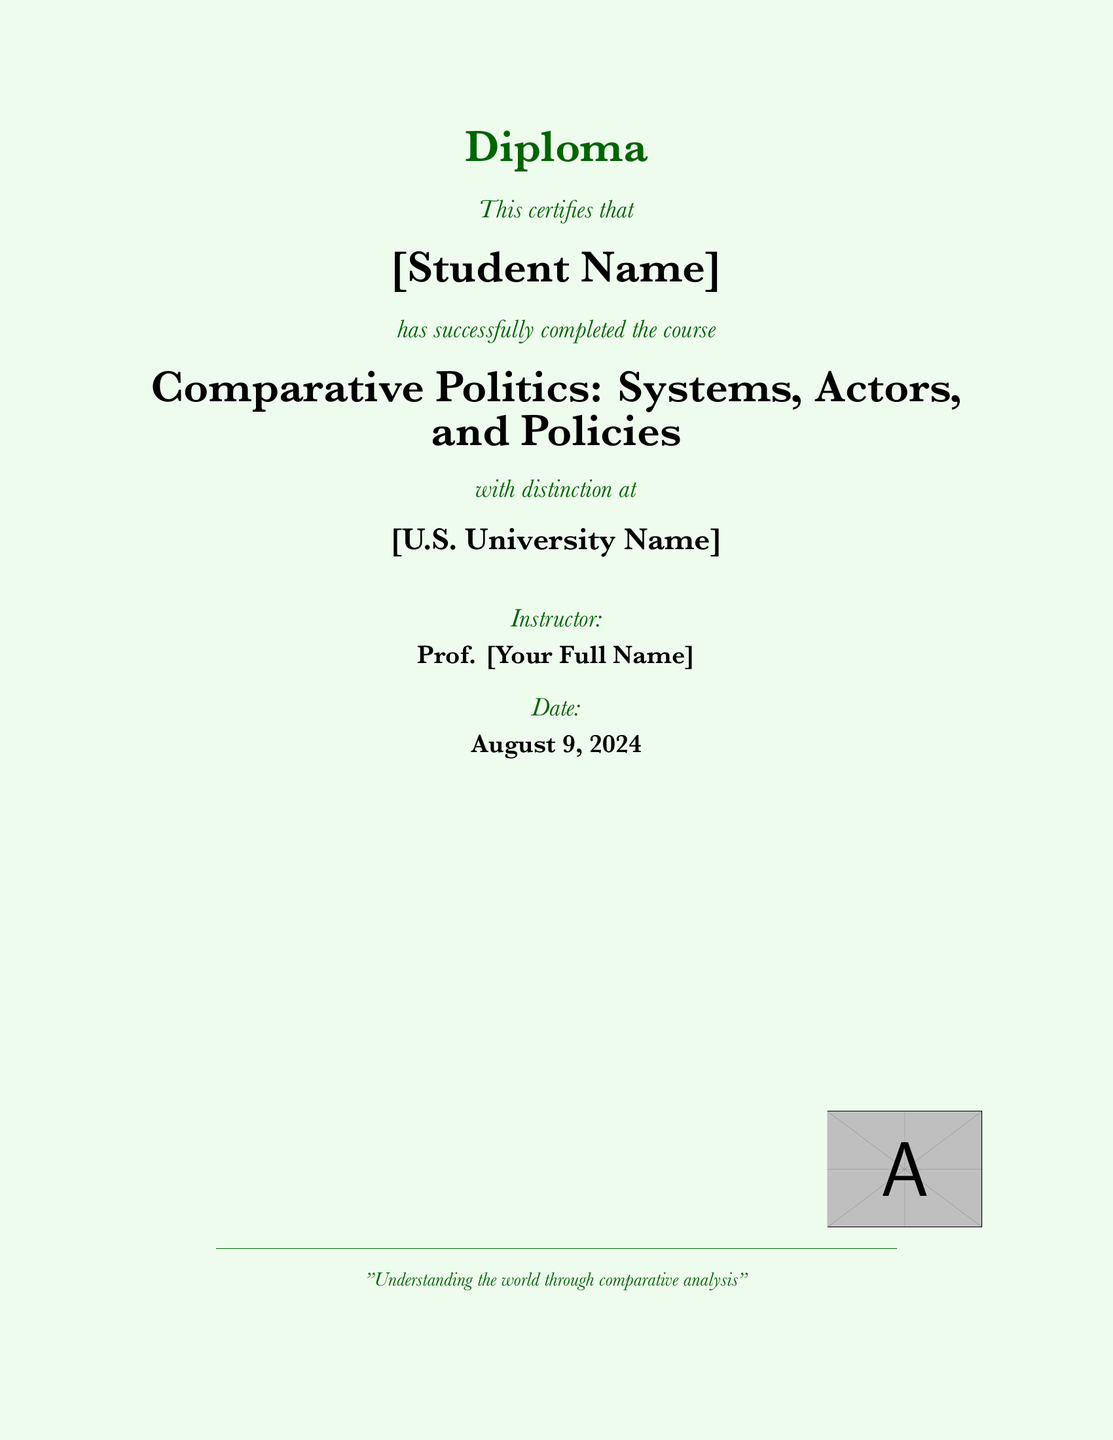what is the title of the course? The title of the course is presented prominently in the document, which is "Comparative Politics: Systems, Actors, and Policies."
Answer: Comparative Politics: Systems, Actors, and Policies who is the instructor for the course? The document explicitly states the instructor's role and name as "Prof. [Your Full Name]."
Answer: Prof. [Your Full Name] what is the certification status of the student? The document indicates that the student has successfully completed the course with distinction.
Answer: has successfully completed the course with distinction what is the color scheme used in the document? The document's colors are described in the code, highlighting light green for the background and dark green for the text.
Answer: light green and dark green what is the issuing institution? The document names the institution where the course was completed as "[U.S. University Name]."
Answer: [U.S. University Name] what is the date of the certification? The date is indicated at the bottom of the document and will typically be the current date when it is generated.
Answer: \today what is the purpose statement included in the document? The document includes a quotation that reflects its educational intent, stating, "Understanding the world through comparative analysis."
Answer: Understanding the world through comparative analysis 